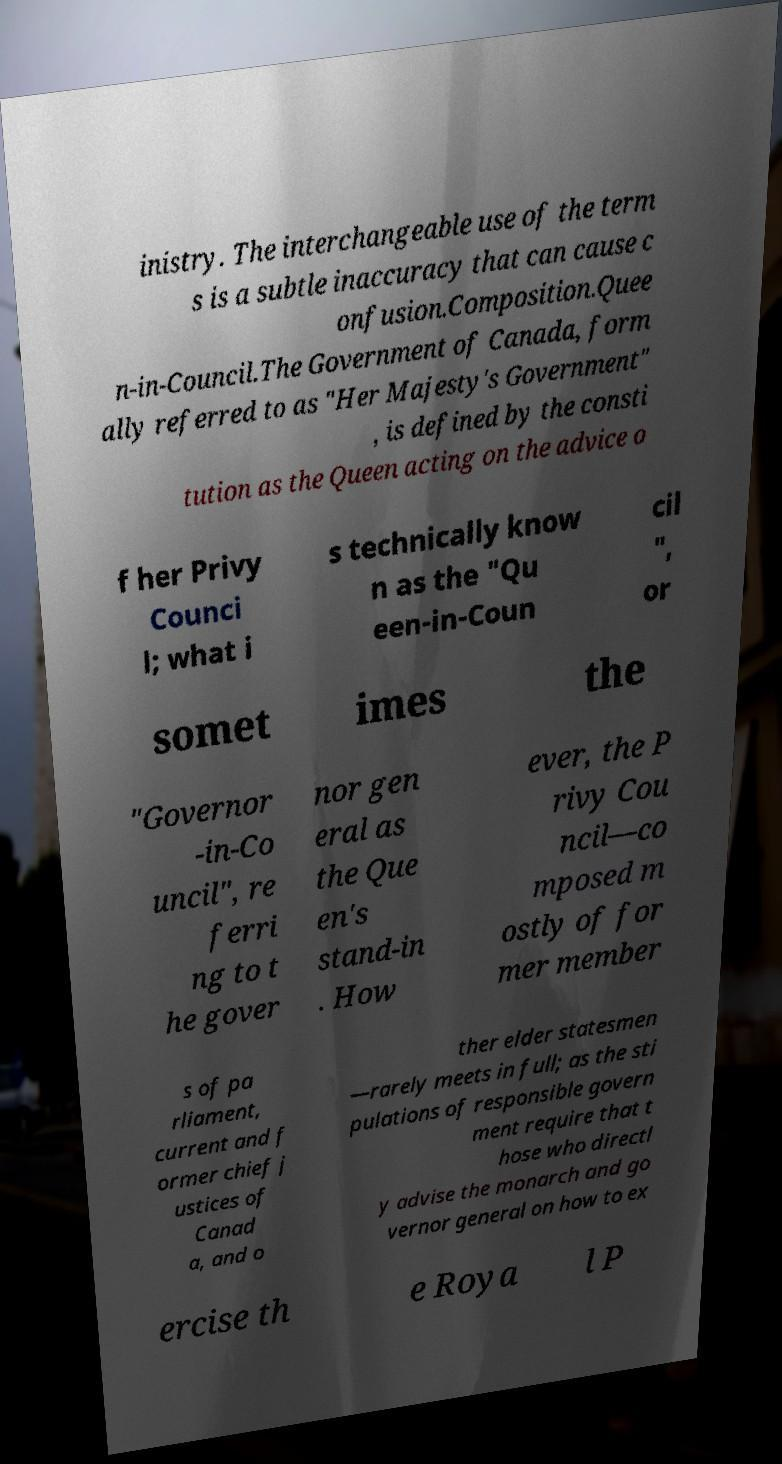Please read and relay the text visible in this image. What does it say? inistry. The interchangeable use of the term s is a subtle inaccuracy that can cause c onfusion.Composition.Quee n-in-Council.The Government of Canada, form ally referred to as "Her Majesty's Government" , is defined by the consti tution as the Queen acting on the advice o f her Privy Counci l; what i s technically know n as the "Qu een-in-Coun cil ", or somet imes the "Governor -in-Co uncil", re ferri ng to t he gover nor gen eral as the Que en's stand-in . How ever, the P rivy Cou ncil—co mposed m ostly of for mer member s of pa rliament, current and f ormer chief j ustices of Canad a, and o ther elder statesmen —rarely meets in full; as the sti pulations of responsible govern ment require that t hose who directl y advise the monarch and go vernor general on how to ex ercise th e Roya l P 